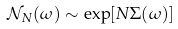Convert formula to latex. <formula><loc_0><loc_0><loc_500><loc_500>\mathcal { N } _ { N } ( \omega ) \sim \exp [ N \Sigma ( \omega ) ]</formula> 